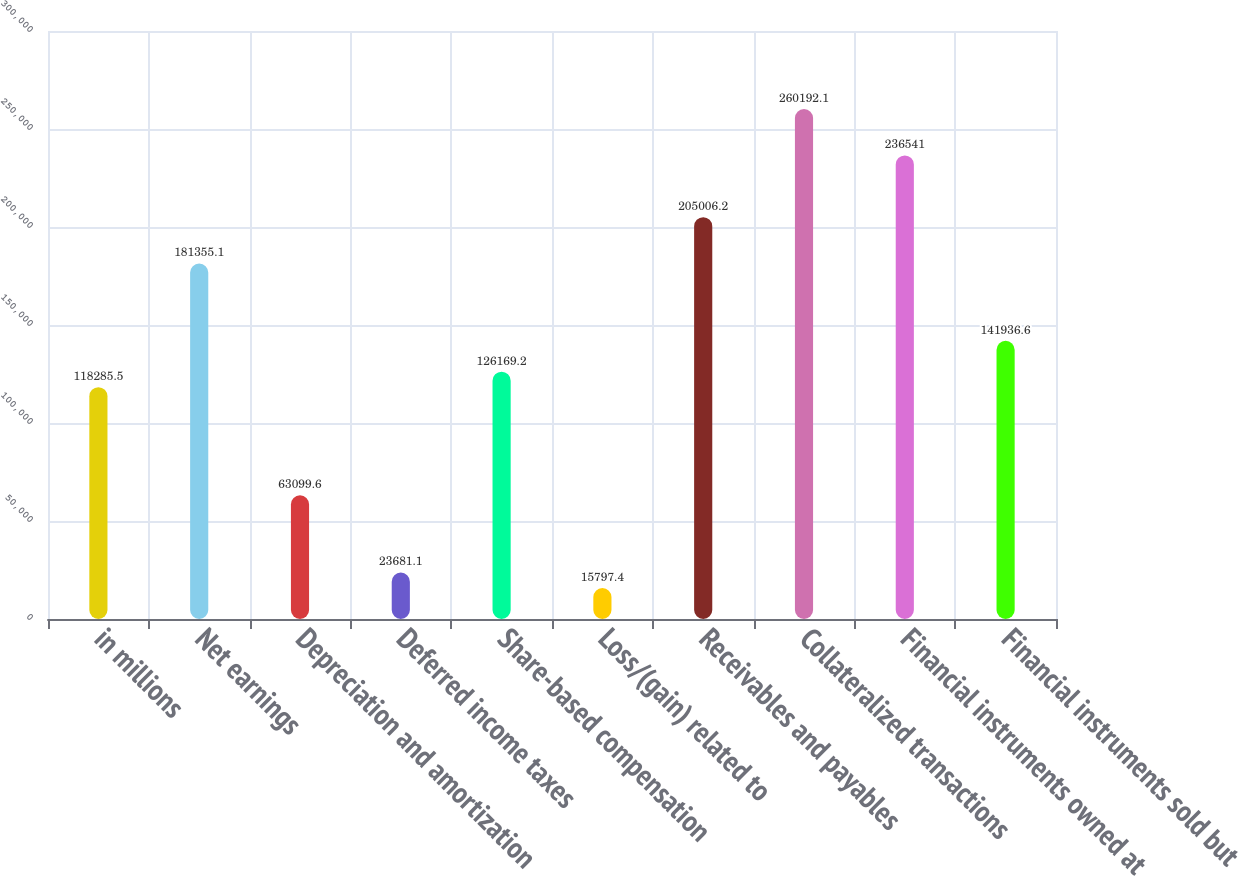Convert chart. <chart><loc_0><loc_0><loc_500><loc_500><bar_chart><fcel>in millions<fcel>Net earnings<fcel>Depreciation and amortization<fcel>Deferred income taxes<fcel>Share-based compensation<fcel>Loss/(gain) related to<fcel>Receivables and payables<fcel>Collateralized transactions<fcel>Financial instruments owned at<fcel>Financial instruments sold but<nl><fcel>118286<fcel>181355<fcel>63099.6<fcel>23681.1<fcel>126169<fcel>15797.4<fcel>205006<fcel>260192<fcel>236541<fcel>141937<nl></chart> 